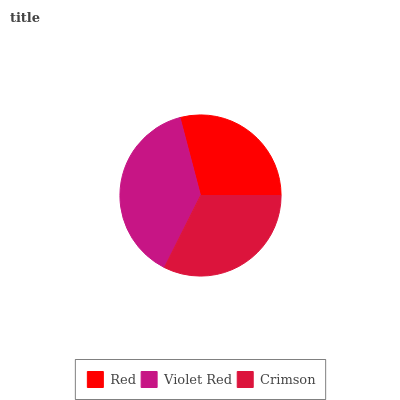Is Red the minimum?
Answer yes or no. Yes. Is Violet Red the maximum?
Answer yes or no. Yes. Is Crimson the minimum?
Answer yes or no. No. Is Crimson the maximum?
Answer yes or no. No. Is Violet Red greater than Crimson?
Answer yes or no. Yes. Is Crimson less than Violet Red?
Answer yes or no. Yes. Is Crimson greater than Violet Red?
Answer yes or no. No. Is Violet Red less than Crimson?
Answer yes or no. No. Is Crimson the high median?
Answer yes or no. Yes. Is Crimson the low median?
Answer yes or no. Yes. Is Red the high median?
Answer yes or no. No. Is Violet Red the low median?
Answer yes or no. No. 